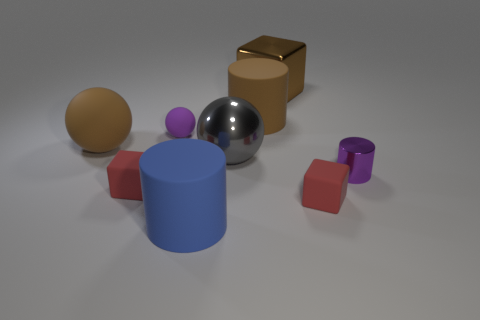Subtract all big spheres. How many spheres are left? 1 Subtract all purple cylinders. How many red cubes are left? 2 Subtract 1 balls. How many balls are left? 2 Subtract all cylinders. How many objects are left? 6 Subtract all yellow cubes. Subtract all red spheres. How many cubes are left? 3 Subtract all small blue metallic cylinders. Subtract all brown cylinders. How many objects are left? 8 Add 4 brown rubber things. How many brown rubber things are left? 6 Add 5 small purple rubber balls. How many small purple rubber balls exist? 6 Subtract 0 red cylinders. How many objects are left? 9 